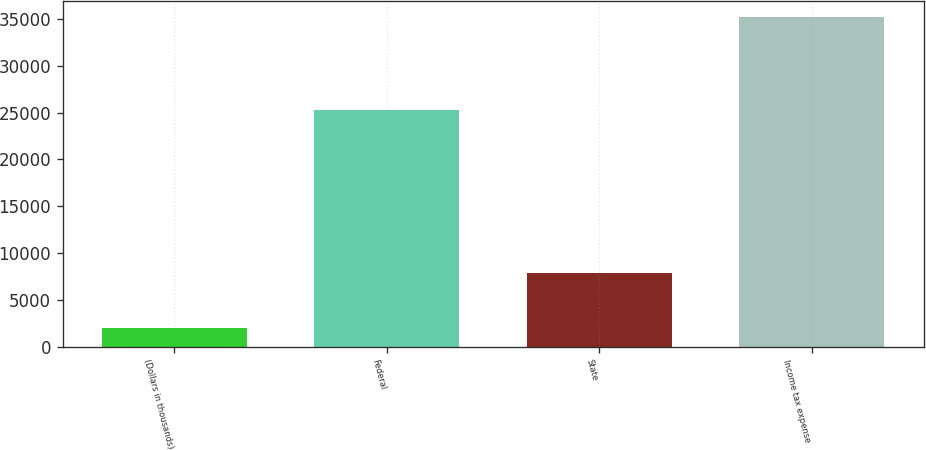Convert chart. <chart><loc_0><loc_0><loc_500><loc_500><bar_chart><fcel>(Dollars in thousands)<fcel>Federal<fcel>State<fcel>Income tax expense<nl><fcel>2009<fcel>25300<fcel>7813<fcel>35207<nl></chart> 